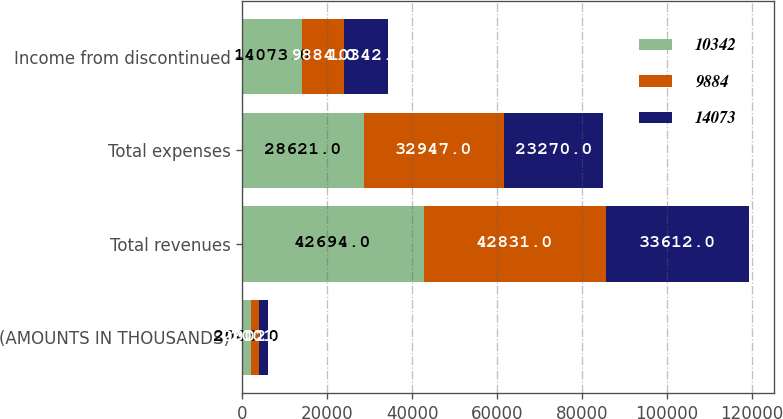Convert chart to OTSL. <chart><loc_0><loc_0><loc_500><loc_500><stacked_bar_chart><ecel><fcel>(AMOUNTS IN THOUSANDS)<fcel>Total revenues<fcel>Total expenses<fcel>Income from discontinued<nl><fcel>10342<fcel>2003<fcel>42694<fcel>28621<fcel>14073<nl><fcel>9884<fcel>2002<fcel>42831<fcel>32947<fcel>9884<nl><fcel>14073<fcel>2001<fcel>33612<fcel>23270<fcel>10342<nl></chart> 